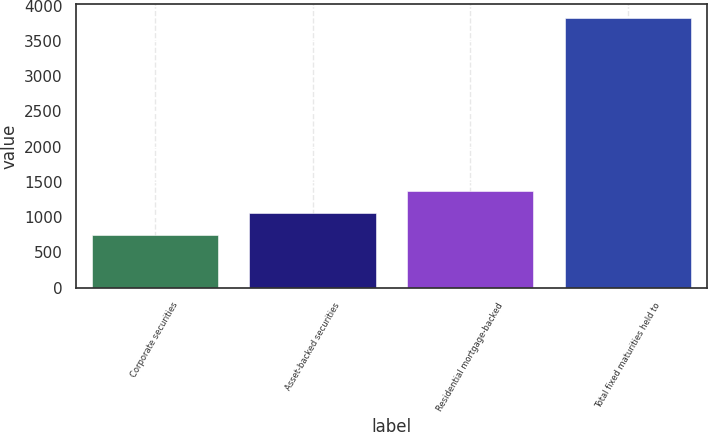<chart> <loc_0><loc_0><loc_500><loc_500><bar_chart><fcel>Corporate securities<fcel>Asset-backed securities<fcel>Residential mortgage-backed<fcel>Total fixed maturities held to<nl><fcel>748<fcel>1056.4<fcel>1364.8<fcel>3832<nl></chart> 